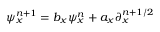<formula> <loc_0><loc_0><loc_500><loc_500>\psi _ { x } ^ { n + 1 } = b _ { x } \psi _ { x } ^ { n } + a _ { x } \partial _ { x } ^ { n + 1 / 2 }</formula> 